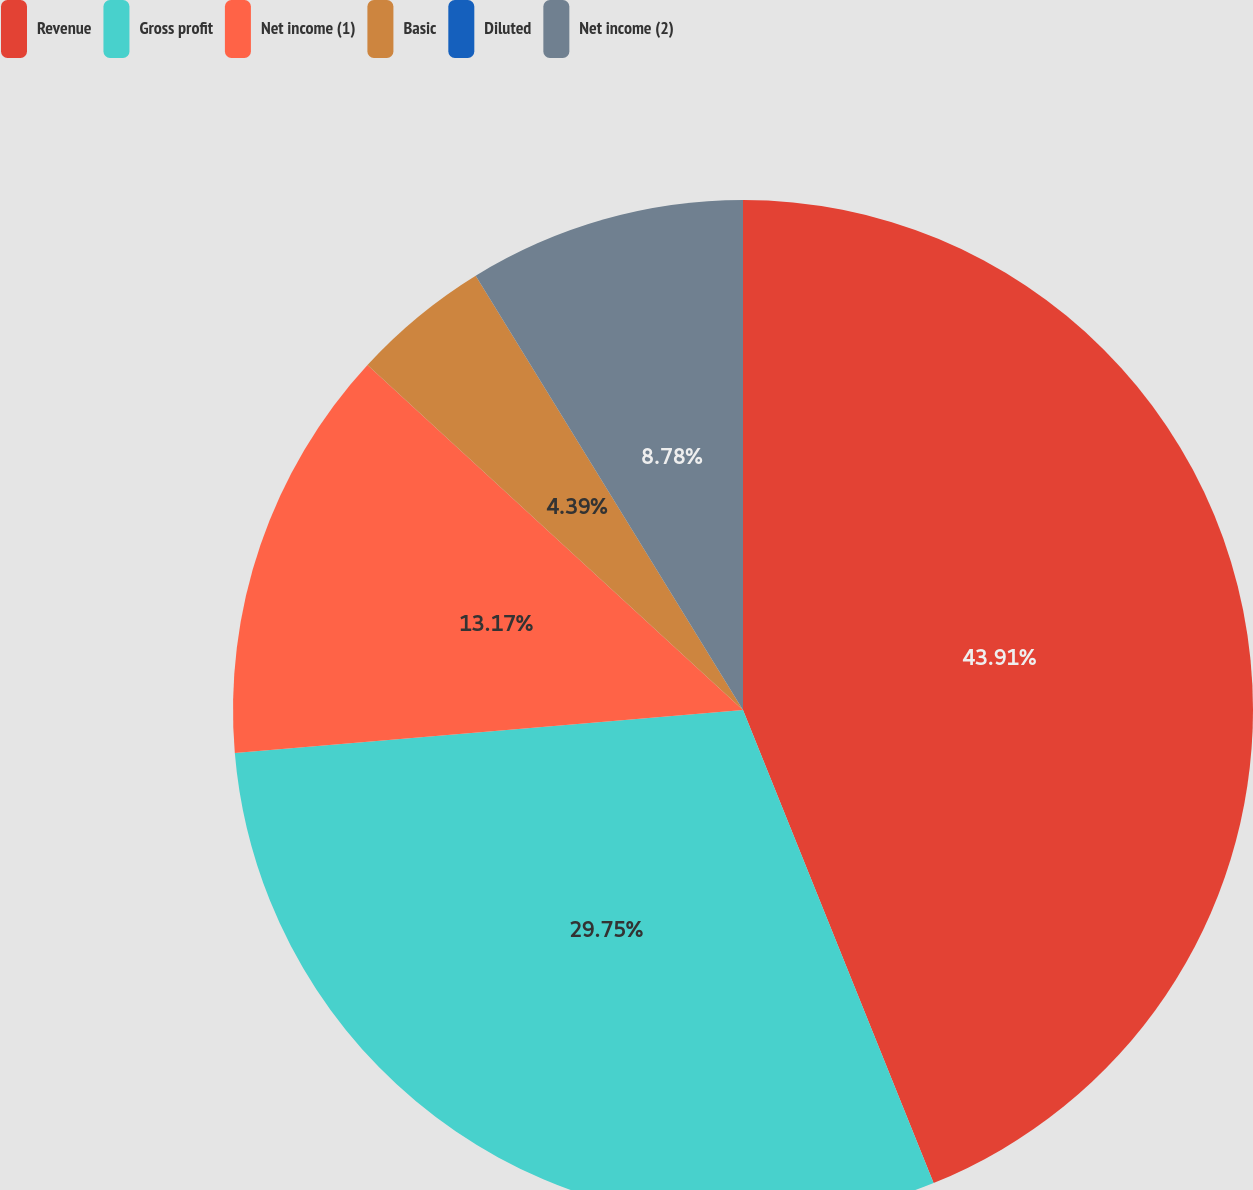<chart> <loc_0><loc_0><loc_500><loc_500><pie_chart><fcel>Revenue<fcel>Gross profit<fcel>Net income (1)<fcel>Basic<fcel>Diluted<fcel>Net income (2)<nl><fcel>43.9%<fcel>29.75%<fcel>13.17%<fcel>4.39%<fcel>0.0%<fcel>8.78%<nl></chart> 